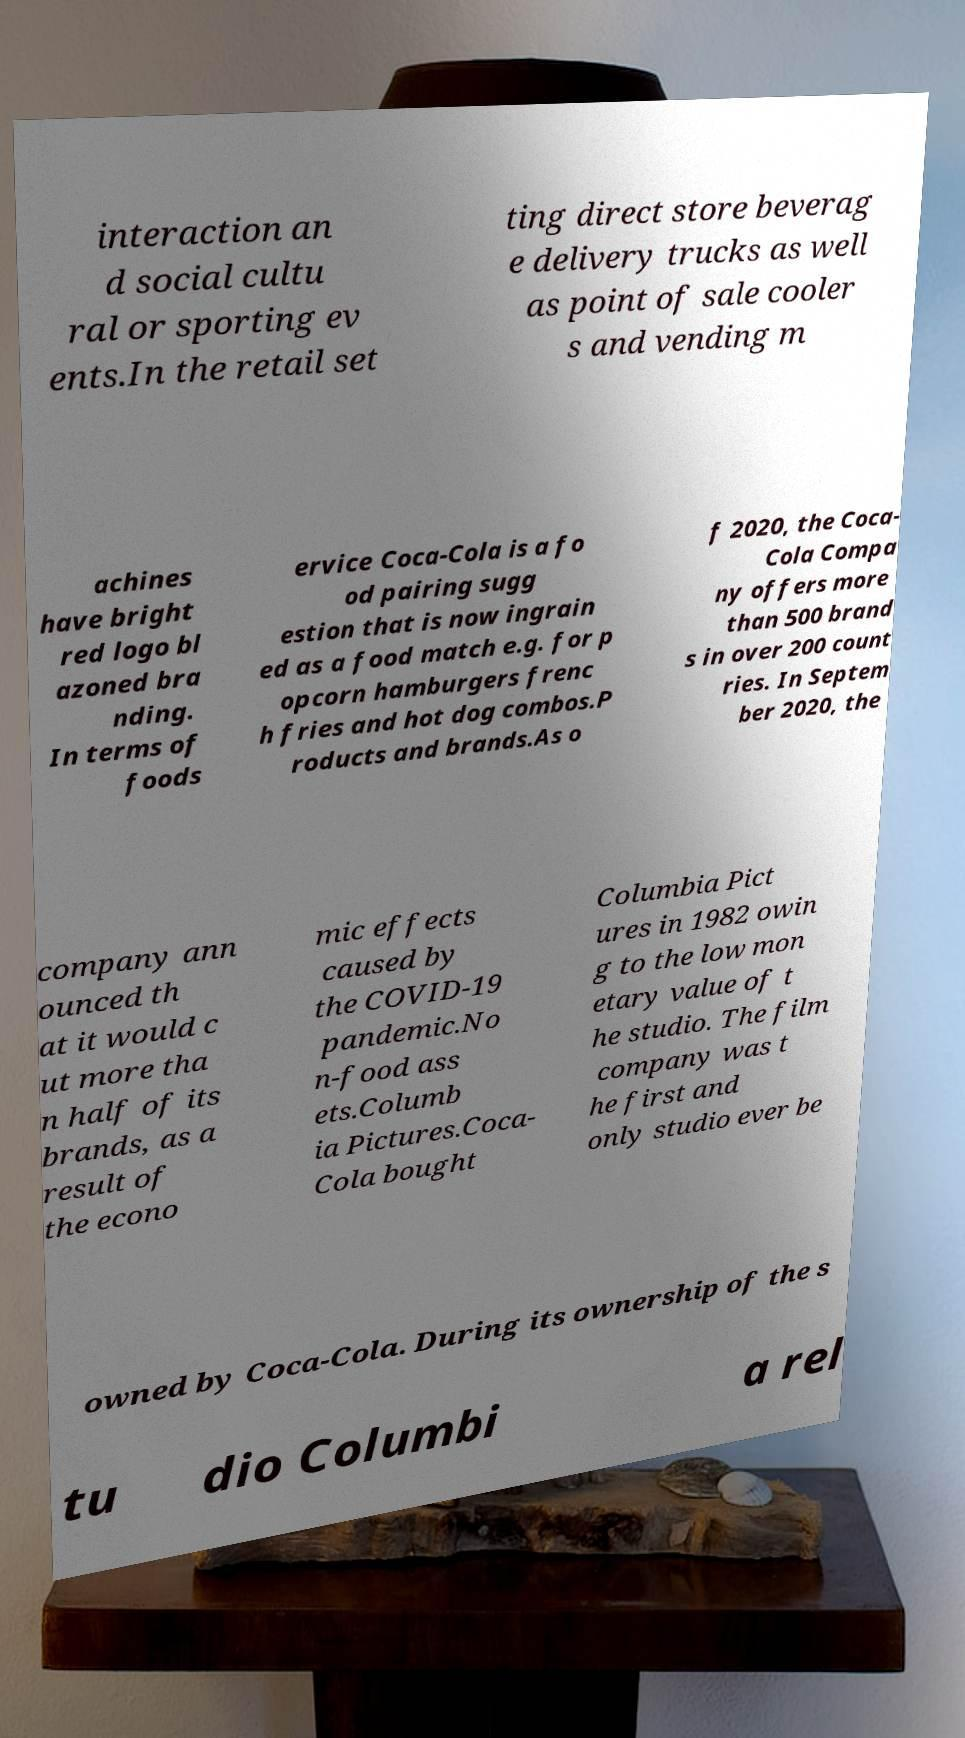Please identify and transcribe the text found in this image. interaction an d social cultu ral or sporting ev ents.In the retail set ting direct store beverag e delivery trucks as well as point of sale cooler s and vending m achines have bright red logo bl azoned bra nding. In terms of foods ervice Coca-Cola is a fo od pairing sugg estion that is now ingrain ed as a food match e.g. for p opcorn hamburgers frenc h fries and hot dog combos.P roducts and brands.As o f 2020, the Coca- Cola Compa ny offers more than 500 brand s in over 200 count ries. In Septem ber 2020, the company ann ounced th at it would c ut more tha n half of its brands, as a result of the econo mic effects caused by the COVID-19 pandemic.No n-food ass ets.Columb ia Pictures.Coca- Cola bought Columbia Pict ures in 1982 owin g to the low mon etary value of t he studio. The film company was t he first and only studio ever be owned by Coca-Cola. During its ownership of the s tu dio Columbi a rel 